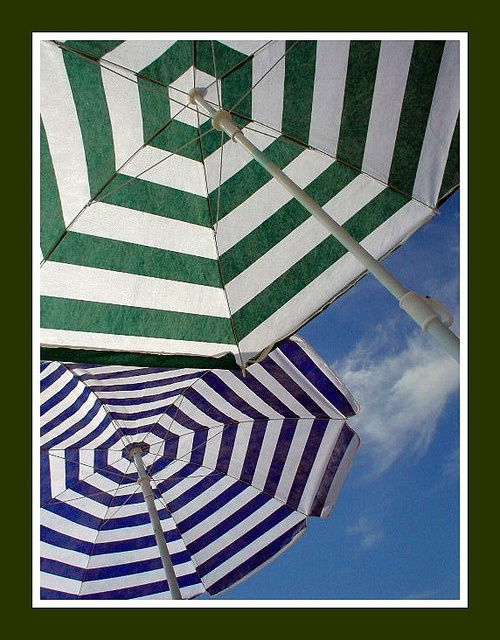Describe the objects in this image and their specific colors. I can see umbrella in darkgreen, lightgray, darkgray, and black tones and umbrella in darkgreen, navy, lightgray, darkgray, and black tones in this image. 